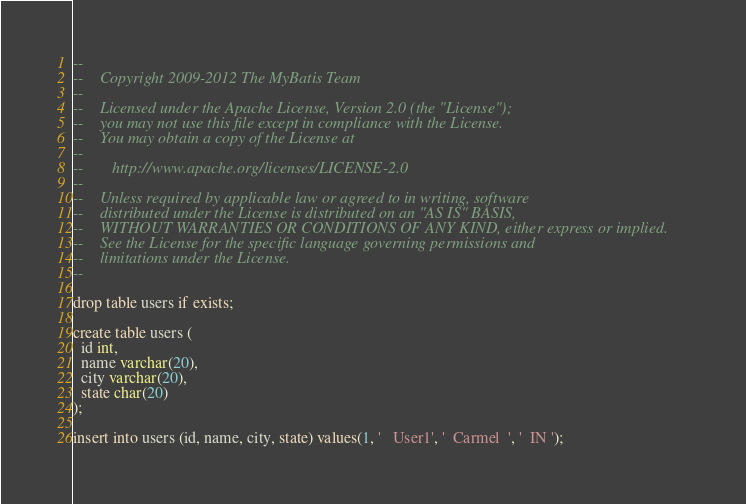<code> <loc_0><loc_0><loc_500><loc_500><_SQL_>--
--    Copyright 2009-2012 The MyBatis Team
--
--    Licensed under the Apache License, Version 2.0 (the "License");
--    you may not use this file except in compliance with the License.
--    You may obtain a copy of the License at
--
--       http://www.apache.org/licenses/LICENSE-2.0
--
--    Unless required by applicable law or agreed to in writing, software
--    distributed under the License is distributed on an "AS IS" BASIS,
--    WITHOUT WARRANTIES OR CONDITIONS OF ANY KIND, either express or implied.
--    See the License for the specific language governing permissions and
--    limitations under the License.
--

drop table users if exists;

create table users (
  id int,
  name varchar(20),
  city varchar(20),
  state char(20)
);

insert into users (id, name, city, state) values(1, '   User1', '  Carmel  ', '  IN ');
</code> 